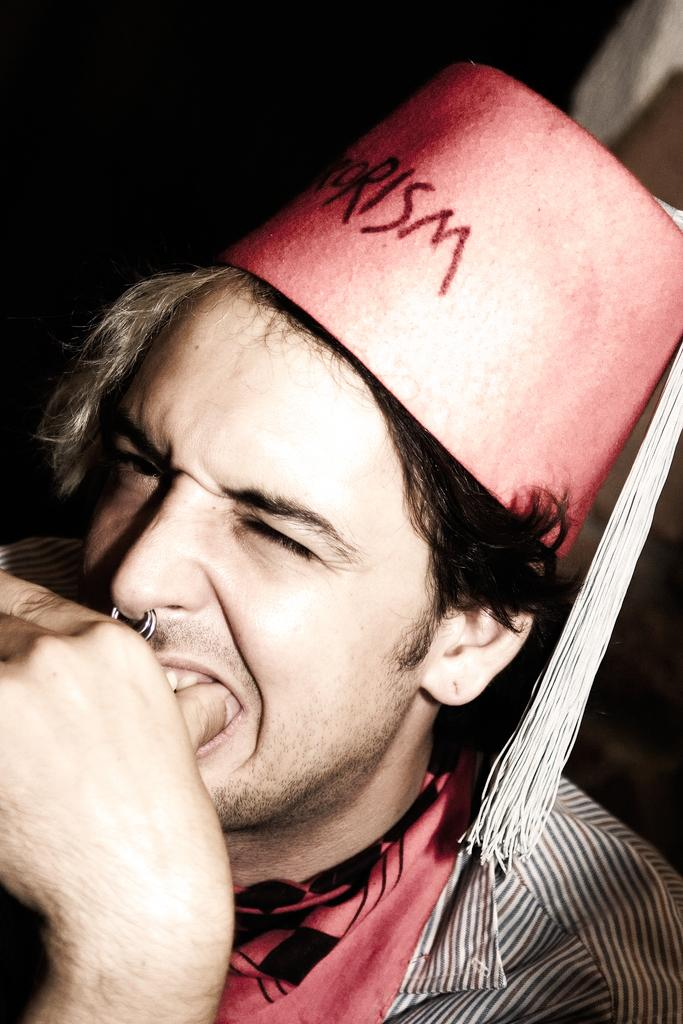What is the main subject of the picture? The main subject of the picture is a man. Can you describe the man's clothing in the picture? The man is wearing a striped shirt and a pink hat. What is the man doing with his finger in the picture? The man has placed his finger in his mouth. How does the man help the air in the picture? There is no mention of air or any assistance being provided in the image. The man is simply placing his finger in his mouth. 